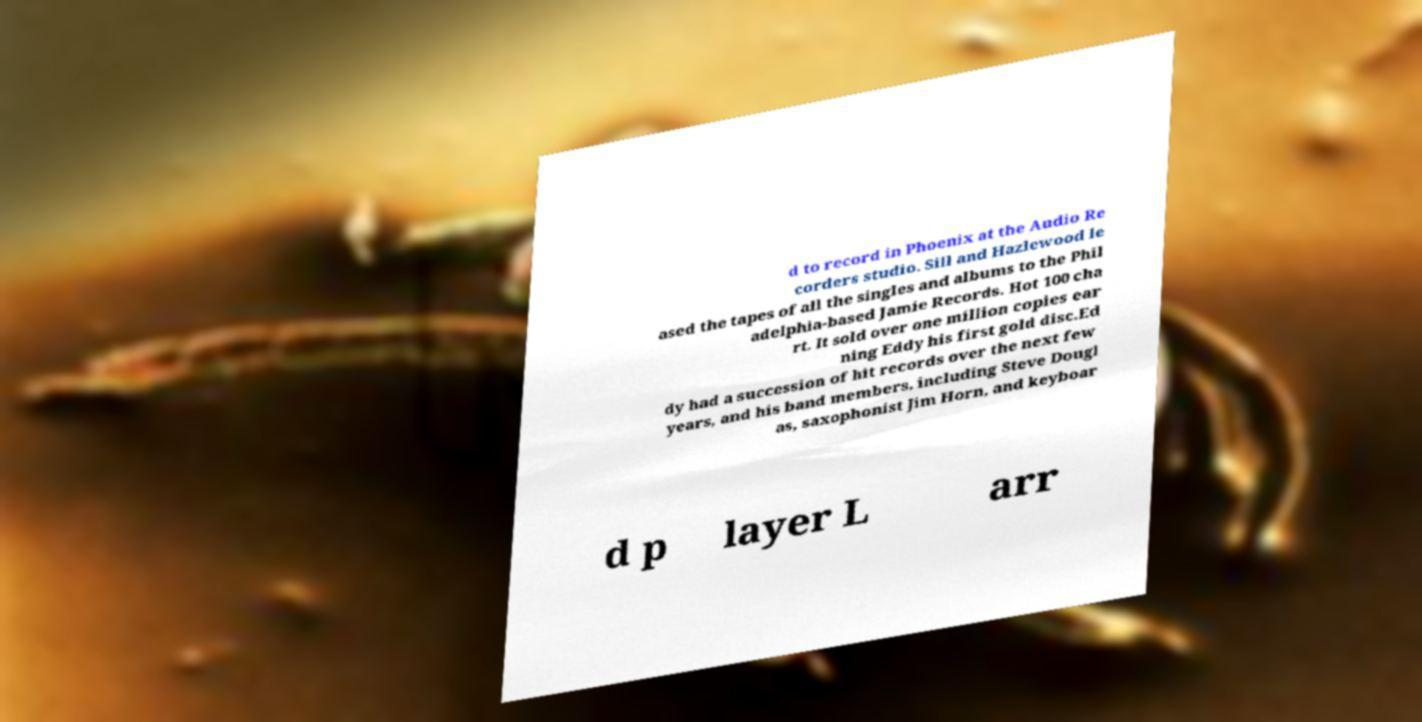Could you extract and type out the text from this image? d to record in Phoenix at the Audio Re corders studio. Sill and Hazlewood le ased the tapes of all the singles and albums to the Phil adelphia-based Jamie Records. Hot 100 cha rt. It sold over one million copies ear ning Eddy his first gold disc.Ed dy had a succession of hit records over the next few years, and his band members, including Steve Dougl as, saxophonist Jim Horn, and keyboar d p layer L arr 